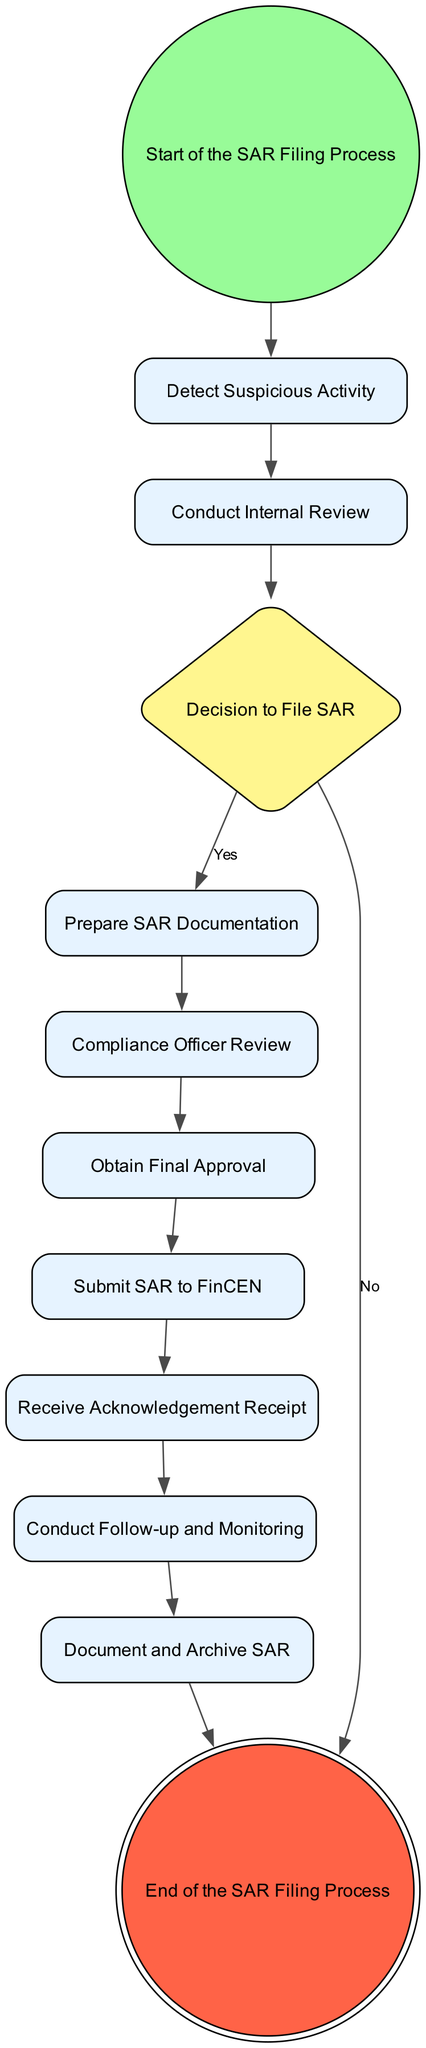What is the first step in the SAR Filing Process? The diagram begins at the "Start of the SAR Filing Process," indicating that this is the first step before any activities occur.
Answer: Start of the SAR Filing Process How many decision points are present in the diagram? The diagram includes one decision point labeled "Decision to File SAR," which requires a yes or no answer.
Answer: 1 Which activity follows after detecting suspicious activity? After "Detect Suspicious Activity," the next activity is "Conduct Internal Review," showing a direct flow from one activity to another.
Answer: Conduct Internal Review What happens if the decision to file a SAR is no? Following a "No" response at the "Decision to File SAR," the process ends immediately without further actions, as indicated in the flow of the diagram.
Answer: End What is the last activity in the SAR Filing Process? The final task in the diagram is "Document and Archive SAR," which signifies the conclusion of all necessary actions related to SAR filing.
Answer: Document and Archive SAR What must be obtained prior to submitting the SAR to FinCEN? The process requires obtaining "Final Approval" from a relevant authority before moving on to "Submit SAR to FinCEN," demonstrating the necessity of this step.
Answer: Final Approval What follows after receiving the acknowledgment receipt? Once the "Receive Acknowledgement Receipt" task is completed, the next action is "Conduct Follow-up and Monitoring," indicating steps toward ensuring proper oversight.
Answer: Conduct Follow-up and Monitoring What percentage of the activities lead to a submission to FinCEN? Out of the nine activities leading up to the "Submit SAR to FinCEN," only one leads to completion, resulting in approximately 11%.
Answer: 11% 